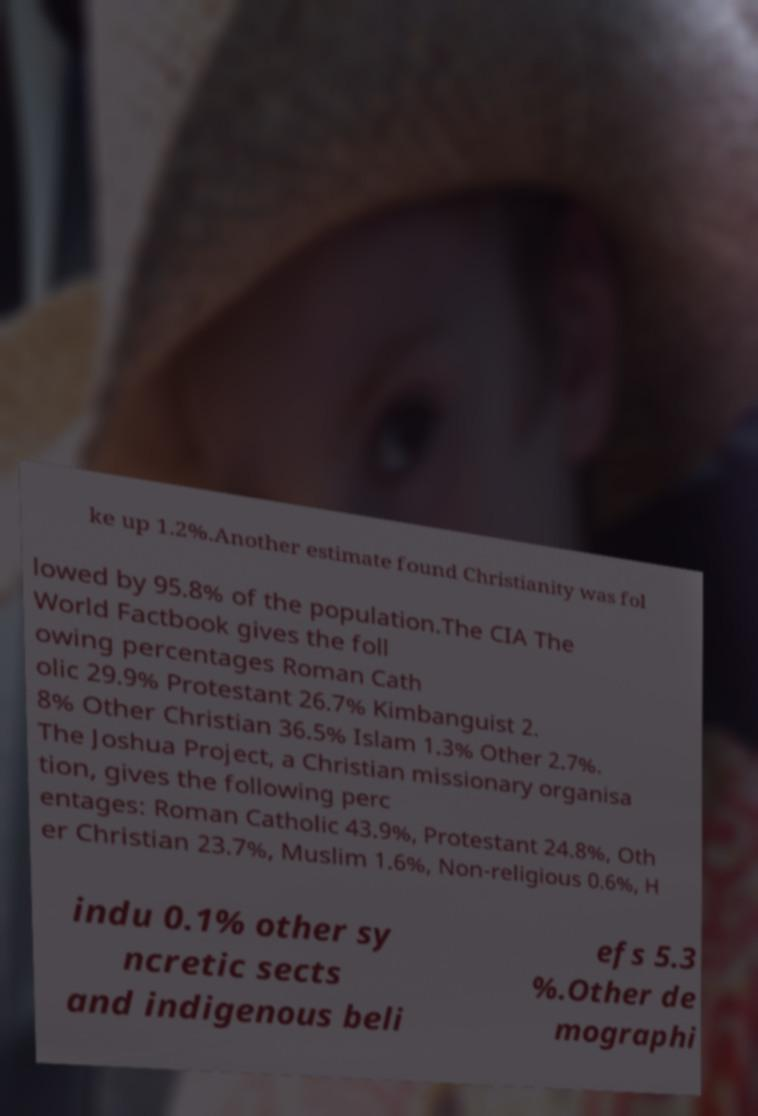Can you read and provide the text displayed in the image?This photo seems to have some interesting text. Can you extract and type it out for me? ke up 1.2%.Another estimate found Christianity was fol lowed by 95.8% of the population.The CIA The World Factbook gives the foll owing percentages Roman Cath olic 29.9% Protestant 26.7% Kimbanguist 2. 8% Other Christian 36.5% Islam 1.3% Other 2.7%. The Joshua Project, a Christian missionary organisa tion, gives the following perc entages: Roman Catholic 43.9%, Protestant 24.8%, Oth er Christian 23.7%, Muslim 1.6%, Non-religious 0.6%, H indu 0.1% other sy ncretic sects and indigenous beli efs 5.3 %.Other de mographi 